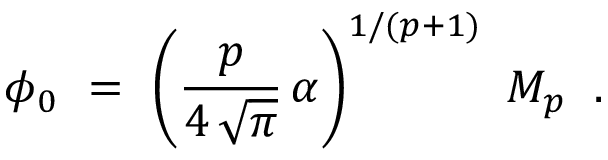<formula> <loc_0><loc_0><loc_500><loc_500>\phi _ { 0 } \ = \ \left ( \frac { p } { 4 \, \sqrt { \pi } } \, \alpha \right ) ^ { 1 / ( p + 1 ) } \ M _ { p } \, .</formula> 